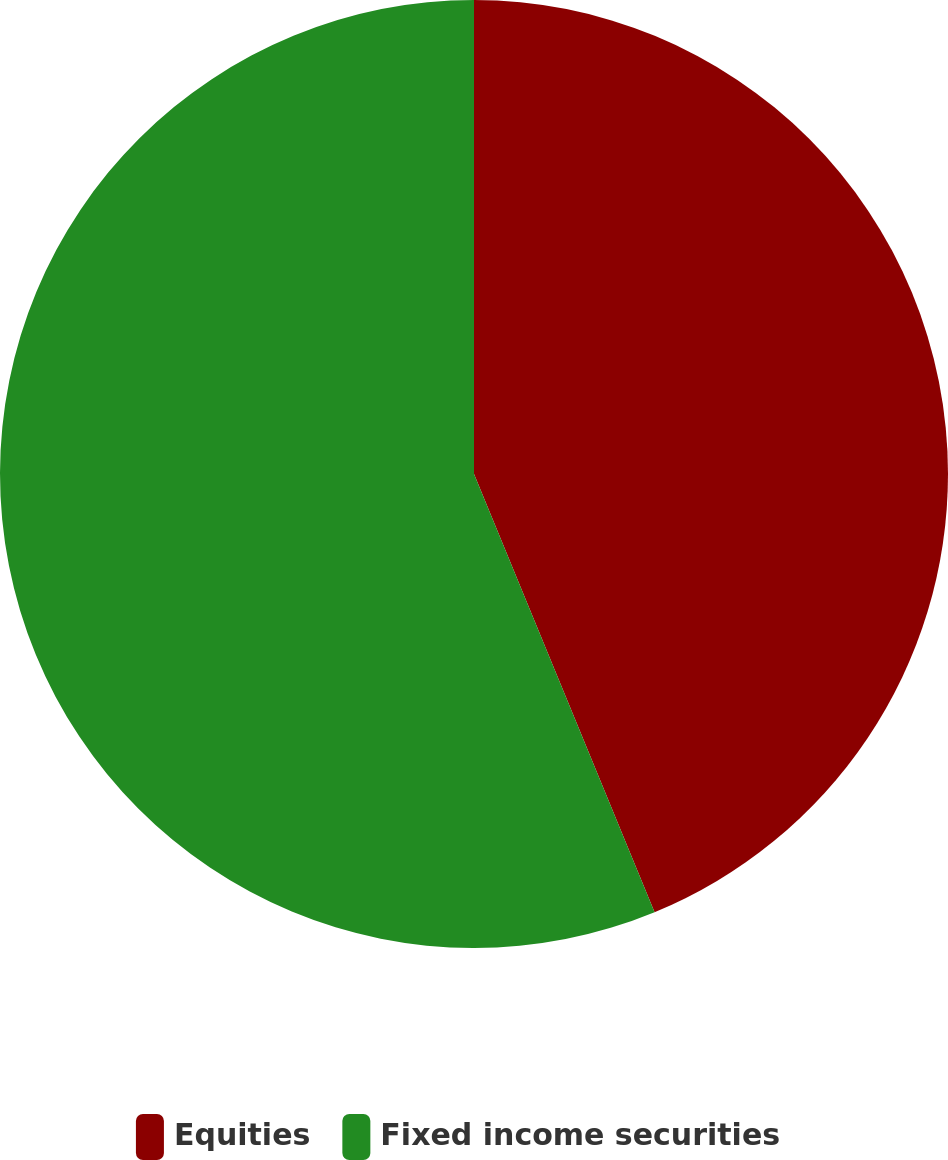Convert chart. <chart><loc_0><loc_0><loc_500><loc_500><pie_chart><fcel>Equities<fcel>Fixed income securities<nl><fcel>43.78%<fcel>56.22%<nl></chart> 